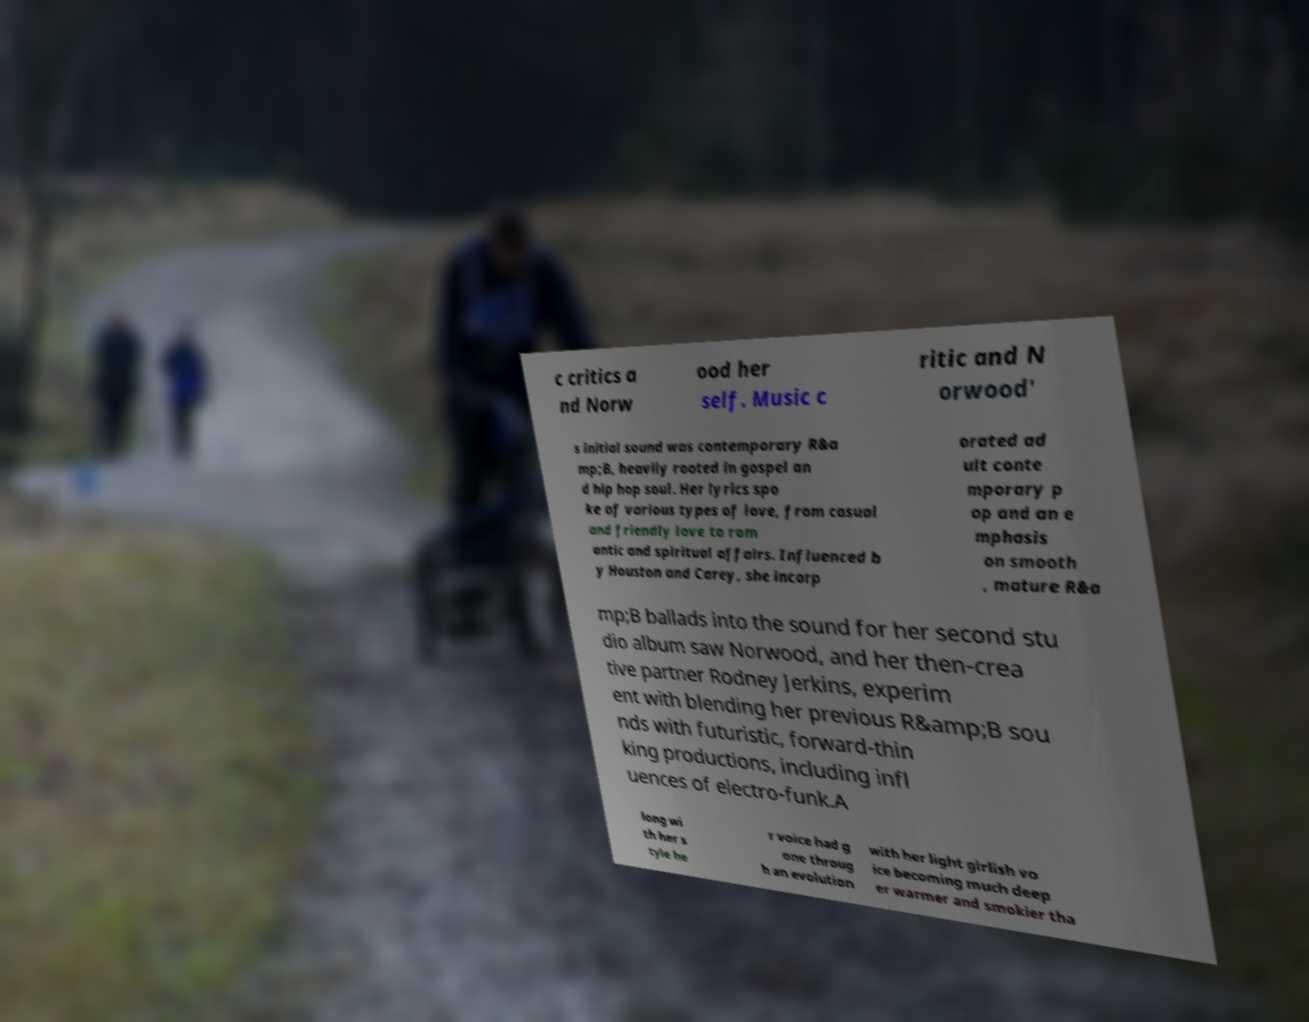What messages or text are displayed in this image? I need them in a readable, typed format. c critics a nd Norw ood her self. Music c ritic and N orwood' s initial sound was contemporary R&a mp;B, heavily rooted in gospel an d hip hop soul. Her lyrics spo ke of various types of love, from casual and friendly love to rom antic and spiritual affairs. Influenced b y Houston and Carey, she incorp orated ad ult conte mporary p op and an e mphasis on smooth , mature R&a mp;B ballads into the sound for her second stu dio album saw Norwood, and her then-crea tive partner Rodney Jerkins, experim ent with blending her previous R&amp;B sou nds with futuristic, forward-thin king productions, including infl uences of electro-funk.A long wi th her s tyle he r voice had g one throug h an evolution with her light girlish vo ice becoming much deep er warmer and smokier tha 